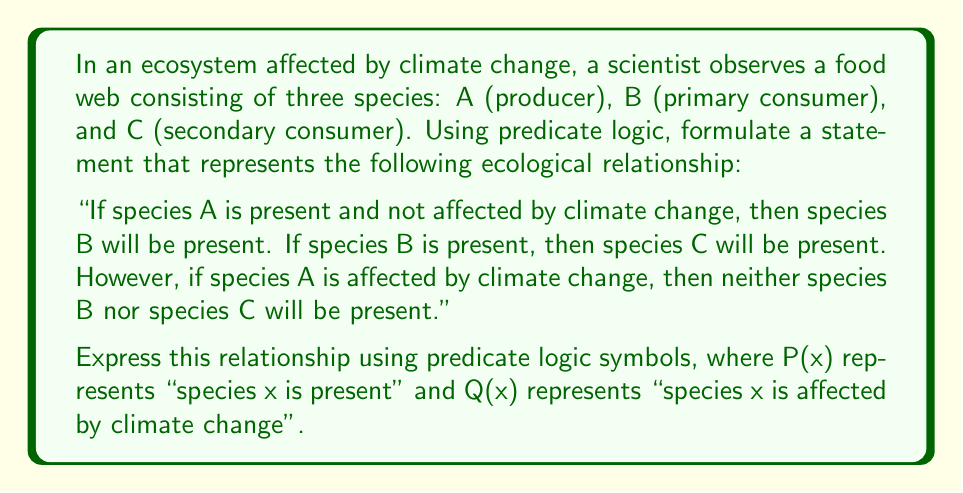Can you answer this question? To formulate this statement using predicate logic, we'll break it down into parts and then combine them:

1. "If species A is present and not affected by climate change, then species B will be present":
   $$(P(A) \land \lnot Q(A)) \rightarrow P(B)$$

2. "If species B is present, then species C will be present":
   $$P(B) \rightarrow P(C)$$

3. "If species A is affected by climate change, then neither species B nor species C will be present":
   $$Q(A) \rightarrow (\lnot P(B) \land \lnot P(C))$$

Now, we need to combine these statements using logical conjunctions ($\land$) to represent the entire relationship:

$$[(P(A) \land \lnot Q(A)) \rightarrow P(B)] \land [P(B) \rightarrow P(C)] \land [Q(A) \rightarrow (\lnot P(B) \land \lnot P(C))]$$

This logical statement encapsulates the entire ecological relationship described in the question, taking into account the presence of species and the impact of climate change on the food web structure.
Answer: $$[(P(A) \land \lnot Q(A)) \rightarrow P(B)] \land [P(B) \rightarrow P(C)] \land [Q(A) \rightarrow (\lnot P(B) \land \lnot P(C))]$$ 